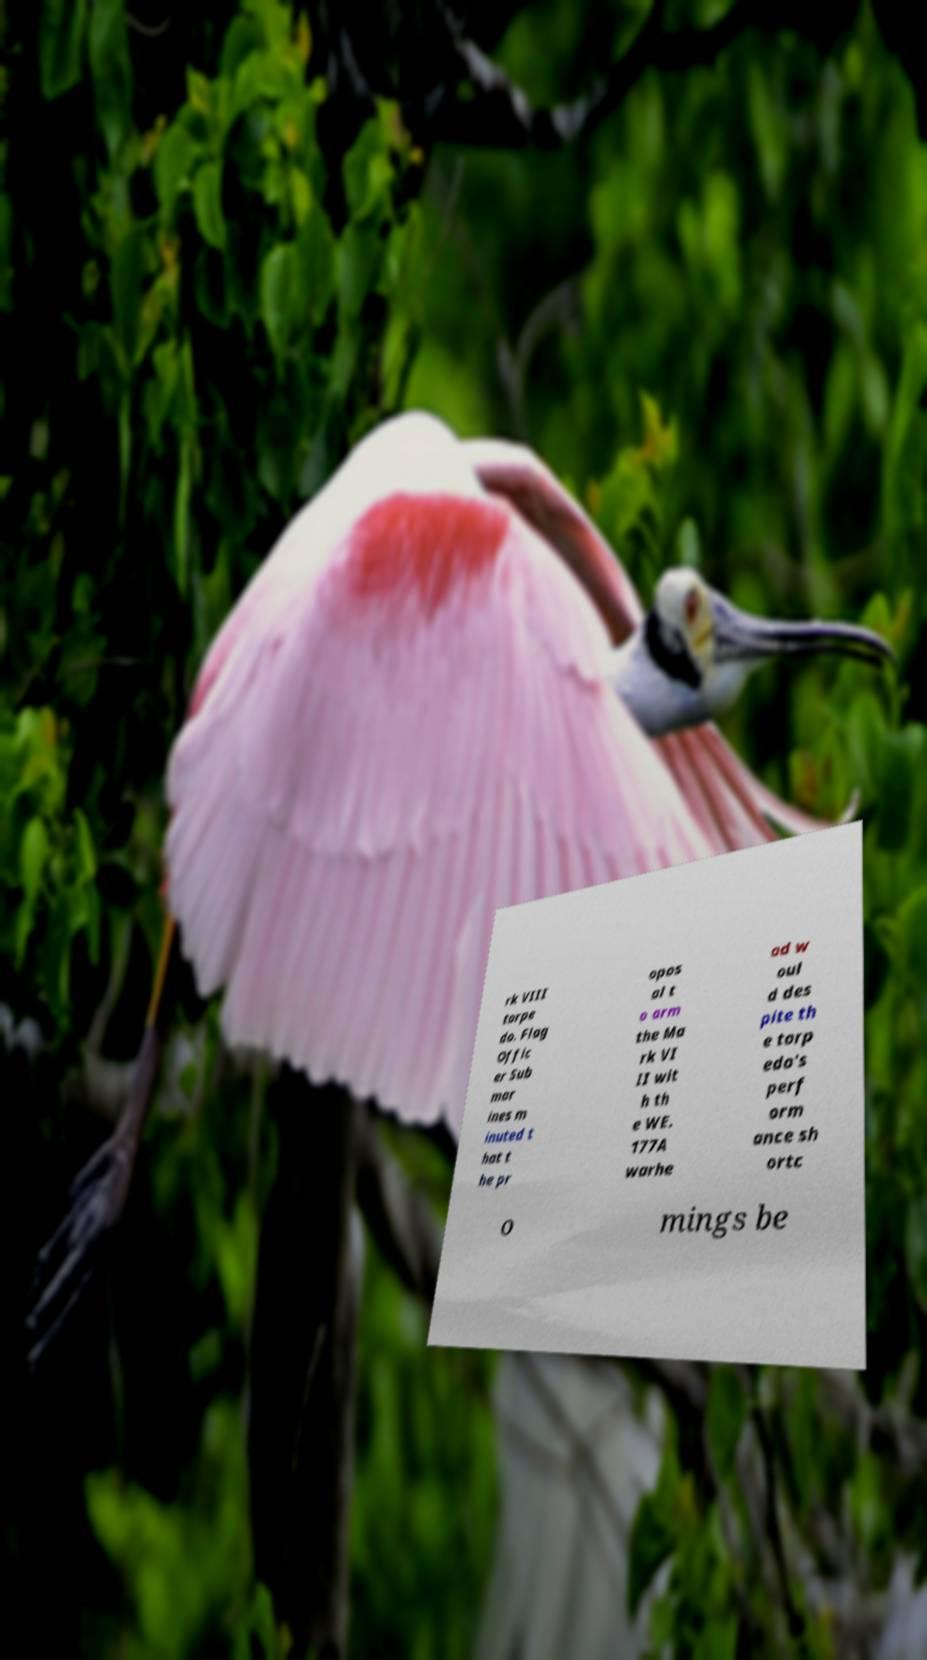I need the written content from this picture converted into text. Can you do that? rk VIII torpe do. Flag Offic er Sub mar ines m inuted t hat t he pr opos al t o arm the Ma rk VI II wit h th e WE. 177A warhe ad w oul d des pite th e torp edo's perf orm ance sh ortc o mings be 